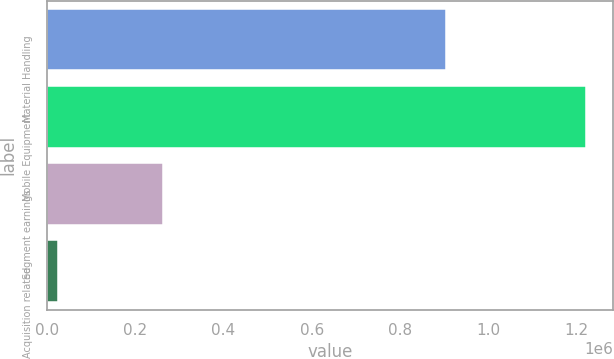<chart> <loc_0><loc_0><loc_500><loc_500><bar_chart><fcel>Material Handling<fcel>Mobile Equipment<fcel>Segment earnings<fcel>Acquisition related<nl><fcel>903570<fcel>1.22072e+06<fcel>264232<fcel>26336<nl></chart> 